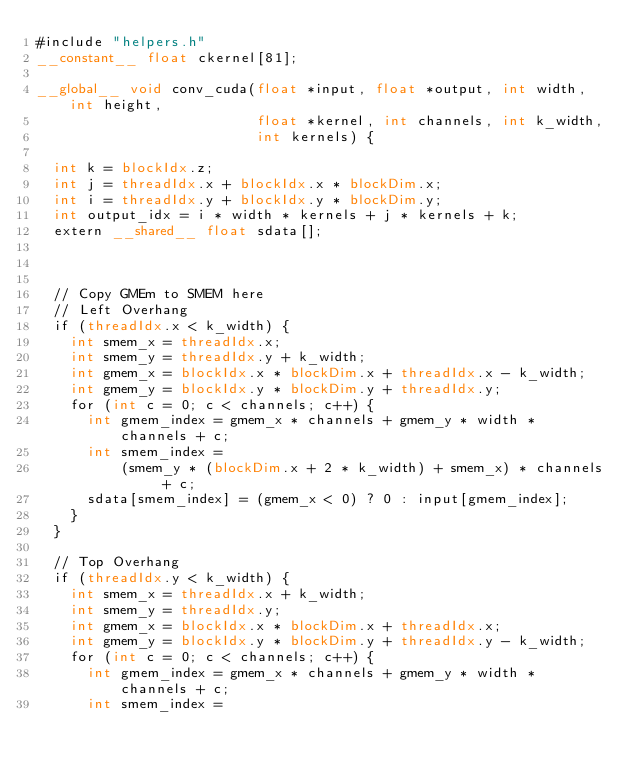<code> <loc_0><loc_0><loc_500><loc_500><_Cuda_>#include "helpers.h"
__constant__ float ckernel[81];

__global__ void conv_cuda(float *input, float *output, int width, int height,
                          float *kernel, int channels, int k_width,
                          int kernels) {

  int k = blockIdx.z;
  int j = threadIdx.x + blockIdx.x * blockDim.x;
  int i = threadIdx.y + blockIdx.y * blockDim.y;
  int output_idx = i * width * kernels + j * kernels + k;
  extern __shared__ float sdata[];



  // Copy GMEm to SMEM here
  // Left Overhang
  if (threadIdx.x < k_width) {
    int smem_x = threadIdx.x;
    int smem_y = threadIdx.y + k_width;
    int gmem_x = blockIdx.x * blockDim.x + threadIdx.x - k_width;
    int gmem_y = blockIdx.y * blockDim.y + threadIdx.y;
    for (int c = 0; c < channels; c++) {
      int gmem_index = gmem_x * channels + gmem_y * width * channels + c;
      int smem_index =
          (smem_y * (blockDim.x + 2 * k_width) + smem_x) * channels + c;
      sdata[smem_index] = (gmem_x < 0) ? 0 : input[gmem_index];
    }
  }

  // Top Overhang
  if (threadIdx.y < k_width) {
    int smem_x = threadIdx.x + k_width;
    int smem_y = threadIdx.y;
    int gmem_x = blockIdx.x * blockDim.x + threadIdx.x;
    int gmem_y = blockIdx.y * blockDim.y + threadIdx.y - k_width;
    for (int c = 0; c < channels; c++) {
      int gmem_index = gmem_x * channels + gmem_y * width * channels + c;
      int smem_index =</code> 